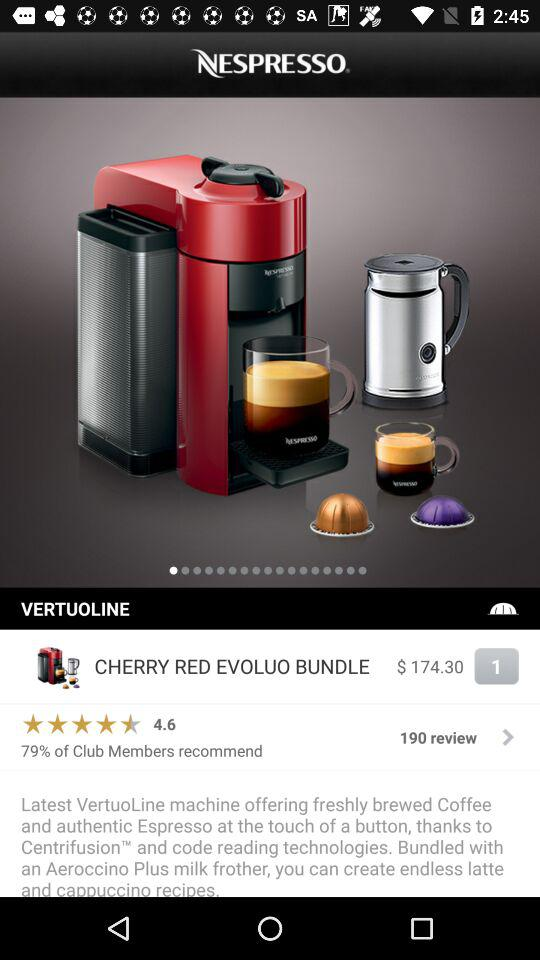What is the color of the product? The color of the product is cherry red. 